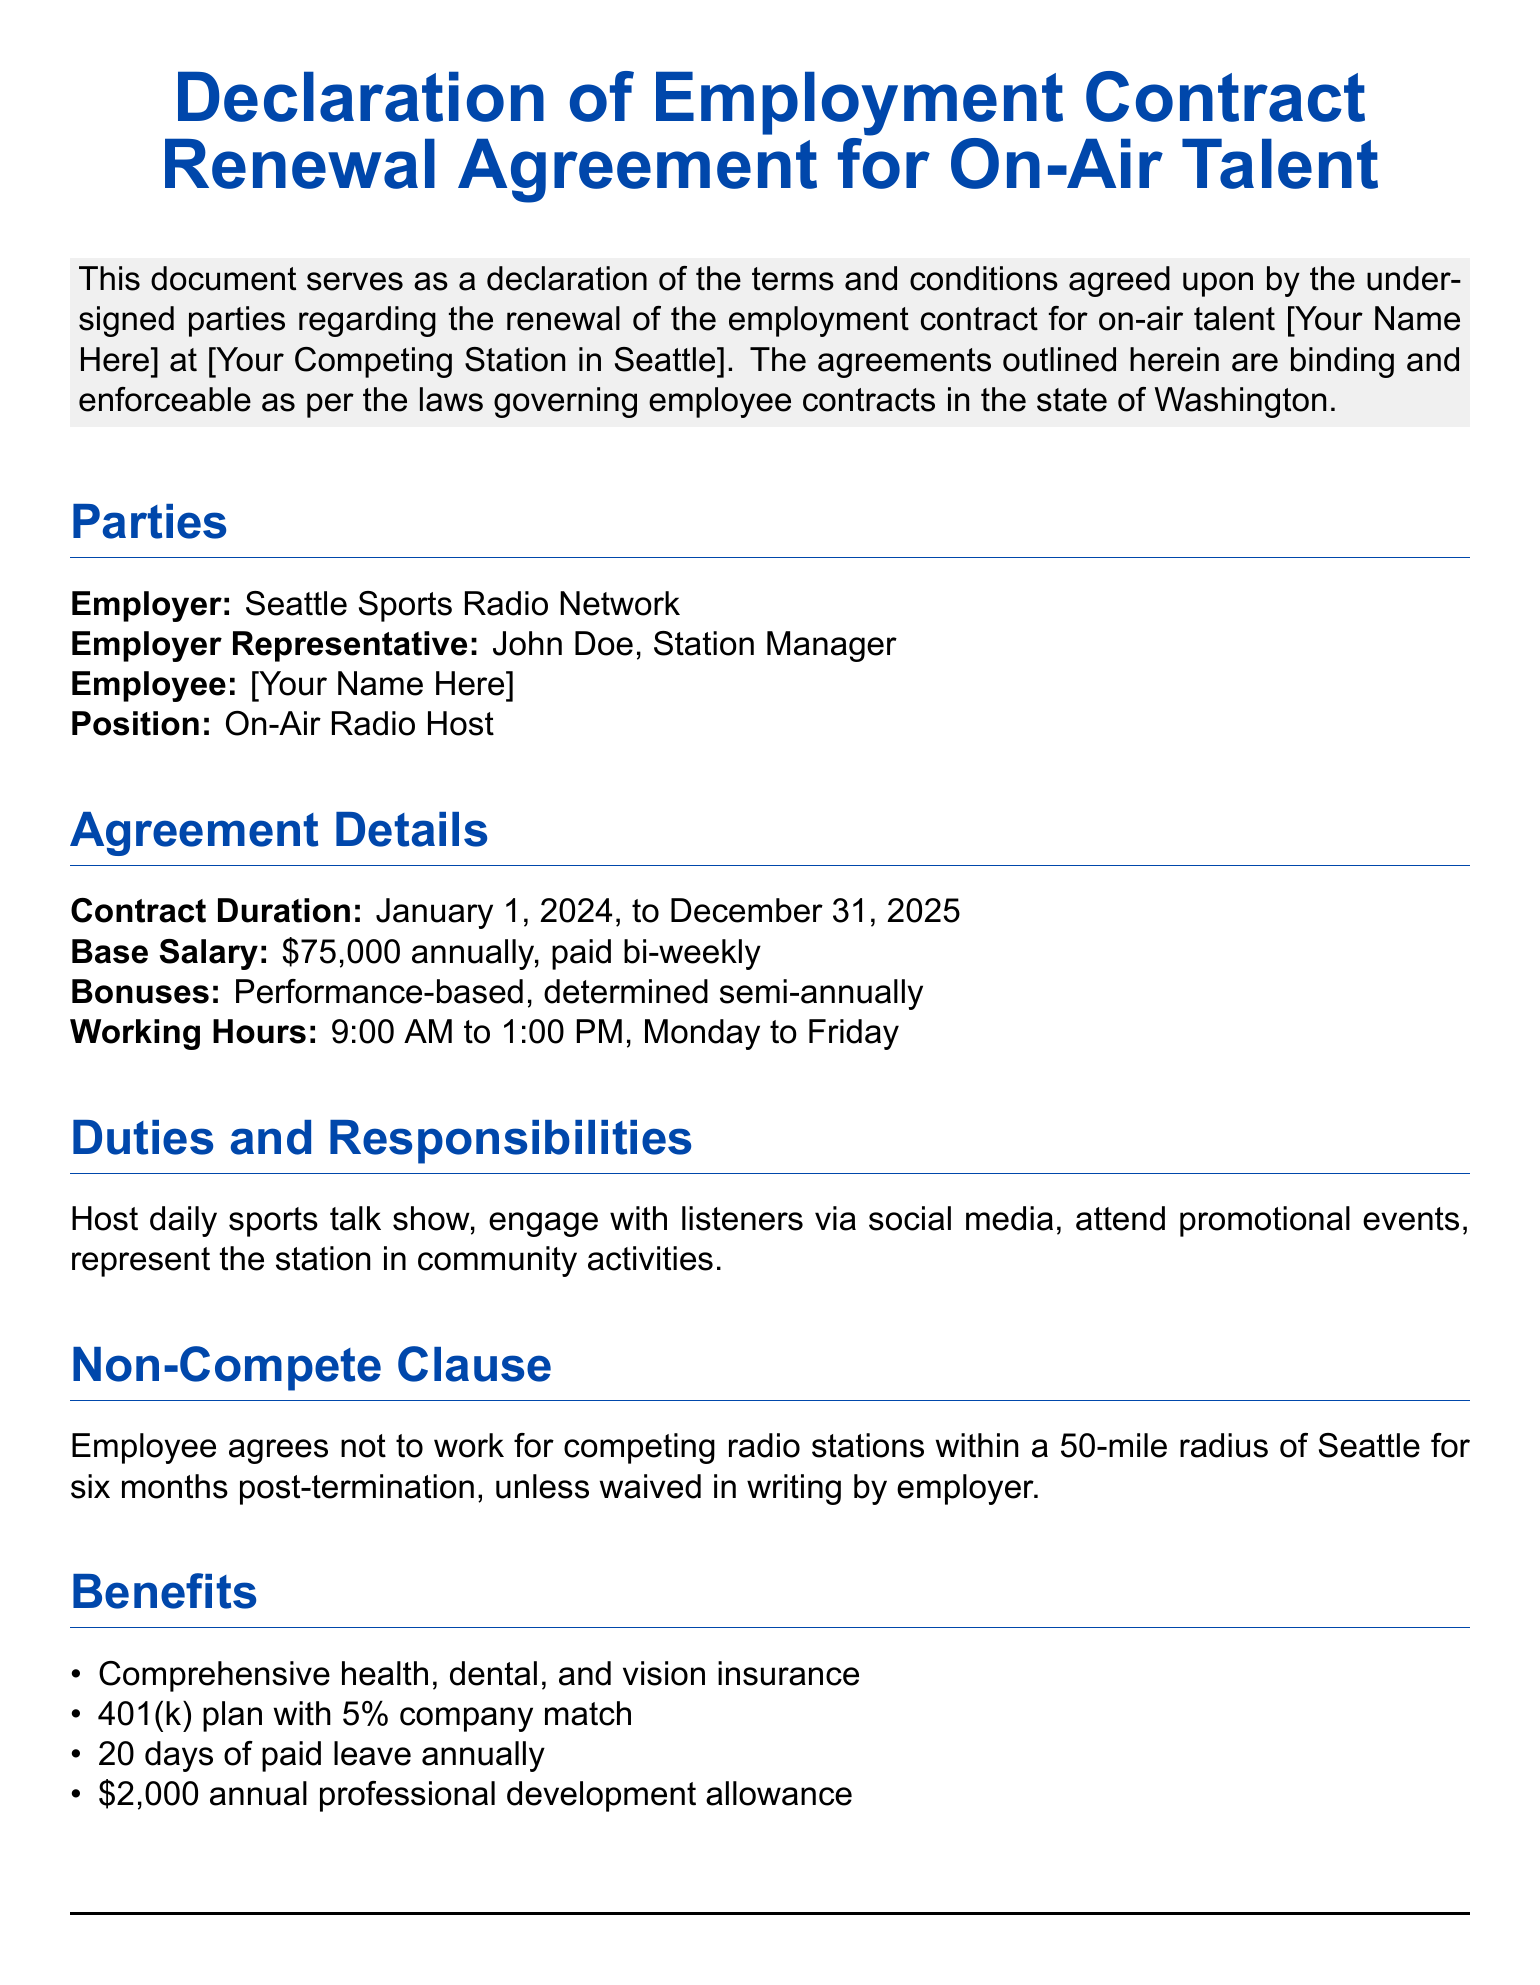What is the employer's name? The employer's name is listed in the document under the Parties section.
Answer: Seattle Sports Radio Network What is the employee's position? The employee's position is mentioned in the Parties section of the document.
Answer: On-Air Radio Host What is the contract duration? The duration of the contract is stated in the Agreement Details section.
Answer: January 1, 2024, to December 31, 2025 What is the annual base salary? The base salary is specified in the Agreement Details section.
Answer: $75,000 annually How often are bonuses determined? The frequency of bonus determination is detailed in the Agreement Details section.
Answer: Semi-annually What is the non-compete radius? The non-compete clause specifies the distance within which the employee cannot work for competing stations.
Answer: 50-mile radius How many days of paid leave are provided annually? The annual paid leave entitlement is noted under the Benefits section.
Answer: 20 days Who is the employer representative? The name of the employer representative can be found in the Parties section.
Answer: John Doe, Station Manager What is the annual professional development allowance? The amount for professional development is mentioned in the Benefits section.
Answer: $2,000 